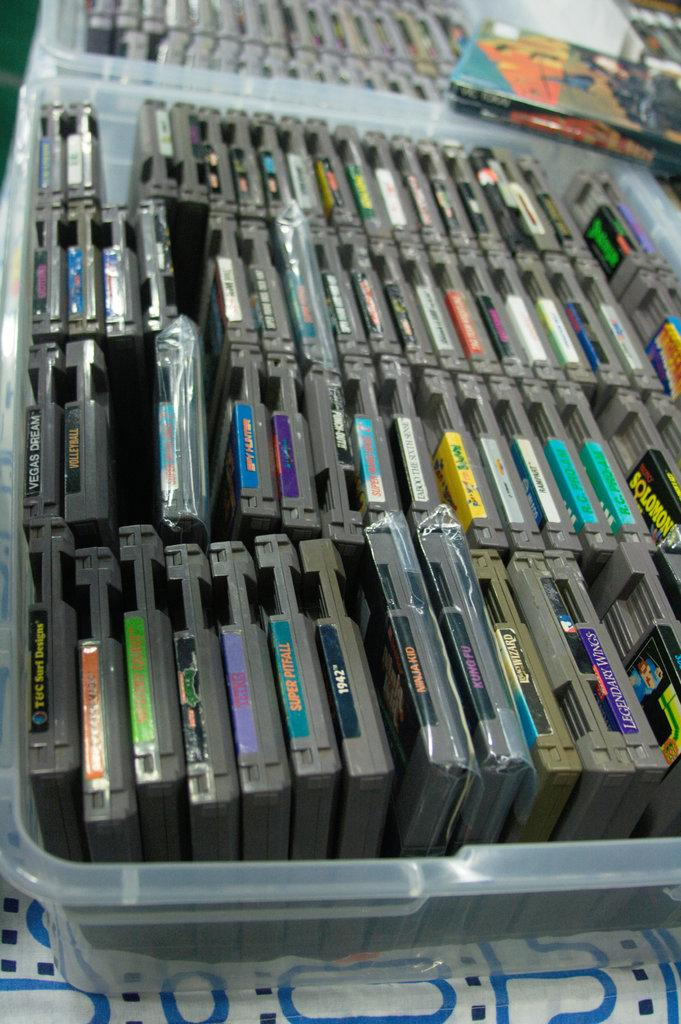What type of electronic devices are visible in the image? There are compact disc drives in the image. How are the compact disc drives stored or protected? The compact disc drives are in plastic boxes. What piece of furniture is present in the image? There is a table in the image. What is covering the table in the image? The table is covered with cloth. What type of bone can be seen on the table in the image? There is no bone present on the table in the image. Can you describe the bite marks on the compact disc drives? There are no bite marks on the compact disc drives in the image. 